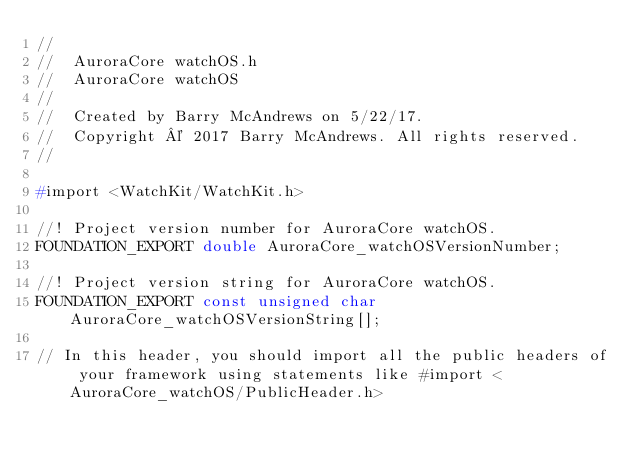<code> <loc_0><loc_0><loc_500><loc_500><_C_>//
//  AuroraCore watchOS.h
//  AuroraCore watchOS
//
//  Created by Barry McAndrews on 5/22/17.
//  Copyright © 2017 Barry McAndrews. All rights reserved.
//

#import <WatchKit/WatchKit.h>

//! Project version number for AuroraCore watchOS.
FOUNDATION_EXPORT double AuroraCore_watchOSVersionNumber;

//! Project version string for AuroraCore watchOS.
FOUNDATION_EXPORT const unsigned char AuroraCore_watchOSVersionString[];

// In this header, you should import all the public headers of your framework using statements like #import <AuroraCore_watchOS/PublicHeader.h>


</code> 